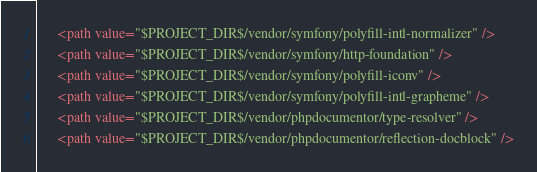Convert code to text. <code><loc_0><loc_0><loc_500><loc_500><_XML_>      <path value="$PROJECT_DIR$/vendor/symfony/polyfill-intl-normalizer" />
      <path value="$PROJECT_DIR$/vendor/symfony/http-foundation" />
      <path value="$PROJECT_DIR$/vendor/symfony/polyfill-iconv" />
      <path value="$PROJECT_DIR$/vendor/symfony/polyfill-intl-grapheme" />
      <path value="$PROJECT_DIR$/vendor/phpdocumentor/type-resolver" />
      <path value="$PROJECT_DIR$/vendor/phpdocumentor/reflection-docblock" /></code> 